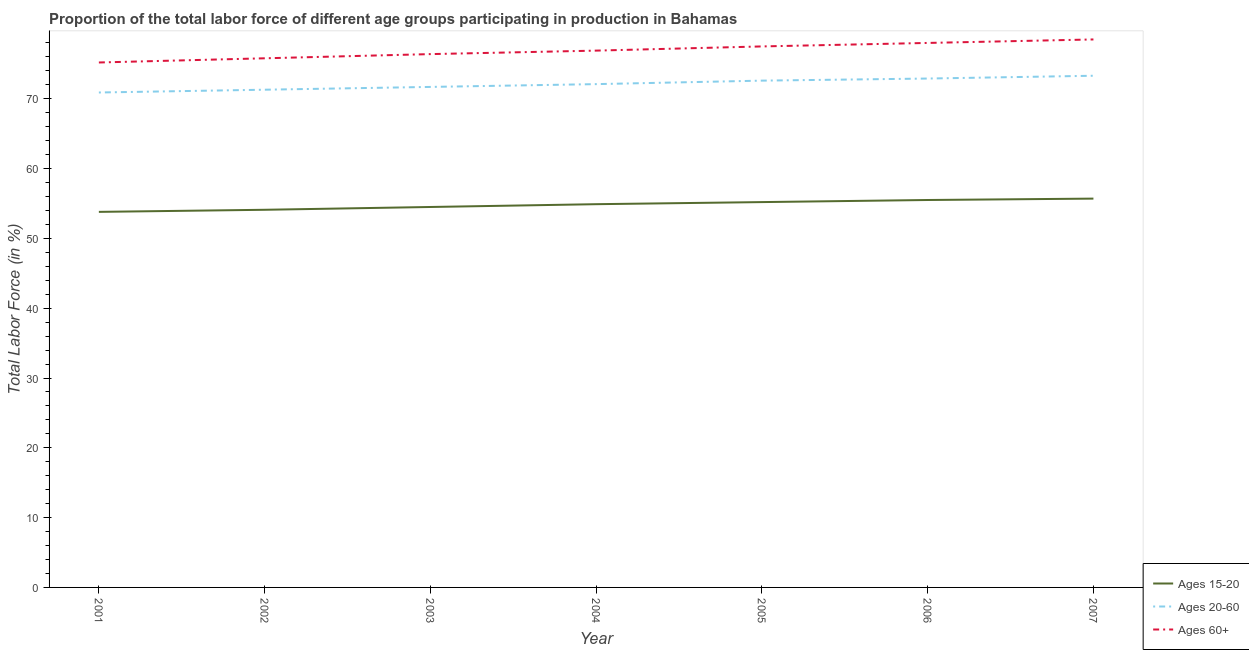What is the percentage of labor force within the age group 15-20 in 2001?
Offer a very short reply. 53.8. Across all years, what is the maximum percentage of labor force above age 60?
Provide a short and direct response. 78.5. Across all years, what is the minimum percentage of labor force within the age group 20-60?
Offer a very short reply. 70.9. In which year was the percentage of labor force within the age group 20-60 minimum?
Offer a terse response. 2001. What is the total percentage of labor force above age 60 in the graph?
Keep it short and to the point. 538.3. What is the difference between the percentage of labor force within the age group 15-20 in 2001 and that in 2005?
Provide a short and direct response. -1.4. What is the difference between the percentage of labor force above age 60 in 2007 and the percentage of labor force within the age group 15-20 in 2001?
Your response must be concise. 24.7. What is the average percentage of labor force within the age group 15-20 per year?
Your answer should be compact. 54.81. In the year 2005, what is the difference between the percentage of labor force within the age group 15-20 and percentage of labor force within the age group 20-60?
Your answer should be very brief. -17.4. In how many years, is the percentage of labor force within the age group 20-60 greater than 74 %?
Provide a short and direct response. 0. What is the ratio of the percentage of labor force above age 60 in 2001 to that in 2002?
Provide a succinct answer. 0.99. Is the percentage of labor force within the age group 20-60 in 2002 less than that in 2005?
Offer a terse response. Yes. Is the difference between the percentage of labor force within the age group 15-20 in 2002 and 2005 greater than the difference between the percentage of labor force within the age group 20-60 in 2002 and 2005?
Keep it short and to the point. Yes. What is the difference between the highest and the second highest percentage of labor force within the age group 15-20?
Provide a short and direct response. 0.2. What is the difference between the highest and the lowest percentage of labor force within the age group 20-60?
Make the answer very short. 2.4. Is the sum of the percentage of labor force within the age group 15-20 in 2002 and 2003 greater than the maximum percentage of labor force above age 60 across all years?
Offer a terse response. Yes. Is it the case that in every year, the sum of the percentage of labor force within the age group 15-20 and percentage of labor force within the age group 20-60 is greater than the percentage of labor force above age 60?
Offer a very short reply. Yes. Does the percentage of labor force above age 60 monotonically increase over the years?
Ensure brevity in your answer.  Yes. Is the percentage of labor force above age 60 strictly greater than the percentage of labor force within the age group 20-60 over the years?
Ensure brevity in your answer.  Yes. How many lines are there?
Offer a terse response. 3. What is the difference between two consecutive major ticks on the Y-axis?
Provide a succinct answer. 10. Where does the legend appear in the graph?
Keep it short and to the point. Bottom right. How many legend labels are there?
Keep it short and to the point. 3. What is the title of the graph?
Provide a succinct answer. Proportion of the total labor force of different age groups participating in production in Bahamas. Does "Taxes on goods and services" appear as one of the legend labels in the graph?
Make the answer very short. No. What is the label or title of the Y-axis?
Your answer should be compact. Total Labor Force (in %). What is the Total Labor Force (in %) of Ages 15-20 in 2001?
Give a very brief answer. 53.8. What is the Total Labor Force (in %) of Ages 20-60 in 2001?
Your answer should be very brief. 70.9. What is the Total Labor Force (in %) in Ages 60+ in 2001?
Make the answer very short. 75.2. What is the Total Labor Force (in %) in Ages 15-20 in 2002?
Your answer should be compact. 54.1. What is the Total Labor Force (in %) of Ages 20-60 in 2002?
Keep it short and to the point. 71.3. What is the Total Labor Force (in %) in Ages 60+ in 2002?
Offer a terse response. 75.8. What is the Total Labor Force (in %) of Ages 15-20 in 2003?
Make the answer very short. 54.5. What is the Total Labor Force (in %) in Ages 20-60 in 2003?
Provide a succinct answer. 71.7. What is the Total Labor Force (in %) of Ages 60+ in 2003?
Ensure brevity in your answer.  76.4. What is the Total Labor Force (in %) in Ages 15-20 in 2004?
Your answer should be compact. 54.9. What is the Total Labor Force (in %) in Ages 20-60 in 2004?
Provide a succinct answer. 72.1. What is the Total Labor Force (in %) in Ages 60+ in 2004?
Ensure brevity in your answer.  76.9. What is the Total Labor Force (in %) of Ages 15-20 in 2005?
Your answer should be compact. 55.2. What is the Total Labor Force (in %) in Ages 20-60 in 2005?
Your response must be concise. 72.6. What is the Total Labor Force (in %) in Ages 60+ in 2005?
Offer a terse response. 77.5. What is the Total Labor Force (in %) in Ages 15-20 in 2006?
Offer a terse response. 55.5. What is the Total Labor Force (in %) in Ages 20-60 in 2006?
Keep it short and to the point. 72.9. What is the Total Labor Force (in %) of Ages 60+ in 2006?
Provide a succinct answer. 78. What is the Total Labor Force (in %) in Ages 15-20 in 2007?
Keep it short and to the point. 55.7. What is the Total Labor Force (in %) of Ages 20-60 in 2007?
Keep it short and to the point. 73.3. What is the Total Labor Force (in %) of Ages 60+ in 2007?
Provide a succinct answer. 78.5. Across all years, what is the maximum Total Labor Force (in %) in Ages 15-20?
Your response must be concise. 55.7. Across all years, what is the maximum Total Labor Force (in %) of Ages 20-60?
Keep it short and to the point. 73.3. Across all years, what is the maximum Total Labor Force (in %) in Ages 60+?
Offer a terse response. 78.5. Across all years, what is the minimum Total Labor Force (in %) of Ages 15-20?
Offer a terse response. 53.8. Across all years, what is the minimum Total Labor Force (in %) of Ages 20-60?
Ensure brevity in your answer.  70.9. Across all years, what is the minimum Total Labor Force (in %) of Ages 60+?
Provide a succinct answer. 75.2. What is the total Total Labor Force (in %) in Ages 15-20 in the graph?
Provide a succinct answer. 383.7. What is the total Total Labor Force (in %) in Ages 20-60 in the graph?
Your answer should be compact. 504.8. What is the total Total Labor Force (in %) of Ages 60+ in the graph?
Provide a short and direct response. 538.3. What is the difference between the Total Labor Force (in %) of Ages 15-20 in 2001 and that in 2002?
Your answer should be very brief. -0.3. What is the difference between the Total Labor Force (in %) of Ages 60+ in 2001 and that in 2002?
Make the answer very short. -0.6. What is the difference between the Total Labor Force (in %) of Ages 15-20 in 2001 and that in 2003?
Offer a very short reply. -0.7. What is the difference between the Total Labor Force (in %) of Ages 20-60 in 2001 and that in 2003?
Offer a very short reply. -0.8. What is the difference between the Total Labor Force (in %) in Ages 20-60 in 2001 and that in 2004?
Provide a short and direct response. -1.2. What is the difference between the Total Labor Force (in %) in Ages 60+ in 2001 and that in 2004?
Give a very brief answer. -1.7. What is the difference between the Total Labor Force (in %) of Ages 20-60 in 2001 and that in 2005?
Keep it short and to the point. -1.7. What is the difference between the Total Labor Force (in %) in Ages 15-20 in 2001 and that in 2007?
Provide a succinct answer. -1.9. What is the difference between the Total Labor Force (in %) of Ages 60+ in 2001 and that in 2007?
Your answer should be compact. -3.3. What is the difference between the Total Labor Force (in %) of Ages 15-20 in 2002 and that in 2003?
Provide a succinct answer. -0.4. What is the difference between the Total Labor Force (in %) of Ages 60+ in 2002 and that in 2003?
Make the answer very short. -0.6. What is the difference between the Total Labor Force (in %) in Ages 15-20 in 2002 and that in 2004?
Your answer should be very brief. -0.8. What is the difference between the Total Labor Force (in %) of Ages 20-60 in 2002 and that in 2004?
Give a very brief answer. -0.8. What is the difference between the Total Labor Force (in %) of Ages 15-20 in 2002 and that in 2005?
Make the answer very short. -1.1. What is the difference between the Total Labor Force (in %) of Ages 20-60 in 2002 and that in 2005?
Your response must be concise. -1.3. What is the difference between the Total Labor Force (in %) of Ages 60+ in 2002 and that in 2005?
Offer a very short reply. -1.7. What is the difference between the Total Labor Force (in %) of Ages 15-20 in 2002 and that in 2006?
Offer a very short reply. -1.4. What is the difference between the Total Labor Force (in %) in Ages 20-60 in 2002 and that in 2006?
Offer a very short reply. -1.6. What is the difference between the Total Labor Force (in %) in Ages 60+ in 2002 and that in 2006?
Keep it short and to the point. -2.2. What is the difference between the Total Labor Force (in %) of Ages 15-20 in 2002 and that in 2007?
Your response must be concise. -1.6. What is the difference between the Total Labor Force (in %) in Ages 20-60 in 2003 and that in 2004?
Offer a very short reply. -0.4. What is the difference between the Total Labor Force (in %) of Ages 60+ in 2003 and that in 2005?
Ensure brevity in your answer.  -1.1. What is the difference between the Total Labor Force (in %) of Ages 20-60 in 2003 and that in 2006?
Your answer should be very brief. -1.2. What is the difference between the Total Labor Force (in %) in Ages 20-60 in 2003 and that in 2007?
Keep it short and to the point. -1.6. What is the difference between the Total Labor Force (in %) of Ages 60+ in 2003 and that in 2007?
Ensure brevity in your answer.  -2.1. What is the difference between the Total Labor Force (in %) in Ages 20-60 in 2004 and that in 2005?
Provide a short and direct response. -0.5. What is the difference between the Total Labor Force (in %) in Ages 60+ in 2004 and that in 2005?
Your answer should be very brief. -0.6. What is the difference between the Total Labor Force (in %) of Ages 15-20 in 2004 and that in 2006?
Make the answer very short. -0.6. What is the difference between the Total Labor Force (in %) in Ages 20-60 in 2004 and that in 2006?
Your answer should be very brief. -0.8. What is the difference between the Total Labor Force (in %) in Ages 60+ in 2004 and that in 2006?
Ensure brevity in your answer.  -1.1. What is the difference between the Total Labor Force (in %) in Ages 60+ in 2004 and that in 2007?
Offer a very short reply. -1.6. What is the difference between the Total Labor Force (in %) in Ages 20-60 in 2005 and that in 2006?
Make the answer very short. -0.3. What is the difference between the Total Labor Force (in %) of Ages 60+ in 2005 and that in 2006?
Make the answer very short. -0.5. What is the difference between the Total Labor Force (in %) of Ages 20-60 in 2005 and that in 2007?
Offer a terse response. -0.7. What is the difference between the Total Labor Force (in %) of Ages 60+ in 2005 and that in 2007?
Make the answer very short. -1. What is the difference between the Total Labor Force (in %) in Ages 20-60 in 2006 and that in 2007?
Offer a very short reply. -0.4. What is the difference between the Total Labor Force (in %) in Ages 60+ in 2006 and that in 2007?
Offer a very short reply. -0.5. What is the difference between the Total Labor Force (in %) in Ages 15-20 in 2001 and the Total Labor Force (in %) in Ages 20-60 in 2002?
Your answer should be very brief. -17.5. What is the difference between the Total Labor Force (in %) in Ages 15-20 in 2001 and the Total Labor Force (in %) in Ages 20-60 in 2003?
Give a very brief answer. -17.9. What is the difference between the Total Labor Force (in %) in Ages 15-20 in 2001 and the Total Labor Force (in %) in Ages 60+ in 2003?
Ensure brevity in your answer.  -22.6. What is the difference between the Total Labor Force (in %) in Ages 20-60 in 2001 and the Total Labor Force (in %) in Ages 60+ in 2003?
Your response must be concise. -5.5. What is the difference between the Total Labor Force (in %) of Ages 15-20 in 2001 and the Total Labor Force (in %) of Ages 20-60 in 2004?
Provide a succinct answer. -18.3. What is the difference between the Total Labor Force (in %) in Ages 15-20 in 2001 and the Total Labor Force (in %) in Ages 60+ in 2004?
Give a very brief answer. -23.1. What is the difference between the Total Labor Force (in %) in Ages 15-20 in 2001 and the Total Labor Force (in %) in Ages 20-60 in 2005?
Ensure brevity in your answer.  -18.8. What is the difference between the Total Labor Force (in %) of Ages 15-20 in 2001 and the Total Labor Force (in %) of Ages 60+ in 2005?
Give a very brief answer. -23.7. What is the difference between the Total Labor Force (in %) in Ages 15-20 in 2001 and the Total Labor Force (in %) in Ages 20-60 in 2006?
Give a very brief answer. -19.1. What is the difference between the Total Labor Force (in %) in Ages 15-20 in 2001 and the Total Labor Force (in %) in Ages 60+ in 2006?
Provide a short and direct response. -24.2. What is the difference between the Total Labor Force (in %) of Ages 15-20 in 2001 and the Total Labor Force (in %) of Ages 20-60 in 2007?
Offer a terse response. -19.5. What is the difference between the Total Labor Force (in %) of Ages 15-20 in 2001 and the Total Labor Force (in %) of Ages 60+ in 2007?
Ensure brevity in your answer.  -24.7. What is the difference between the Total Labor Force (in %) in Ages 20-60 in 2001 and the Total Labor Force (in %) in Ages 60+ in 2007?
Your answer should be compact. -7.6. What is the difference between the Total Labor Force (in %) in Ages 15-20 in 2002 and the Total Labor Force (in %) in Ages 20-60 in 2003?
Offer a terse response. -17.6. What is the difference between the Total Labor Force (in %) of Ages 15-20 in 2002 and the Total Labor Force (in %) of Ages 60+ in 2003?
Offer a very short reply. -22.3. What is the difference between the Total Labor Force (in %) of Ages 20-60 in 2002 and the Total Labor Force (in %) of Ages 60+ in 2003?
Make the answer very short. -5.1. What is the difference between the Total Labor Force (in %) of Ages 15-20 in 2002 and the Total Labor Force (in %) of Ages 20-60 in 2004?
Offer a very short reply. -18. What is the difference between the Total Labor Force (in %) in Ages 15-20 in 2002 and the Total Labor Force (in %) in Ages 60+ in 2004?
Keep it short and to the point. -22.8. What is the difference between the Total Labor Force (in %) in Ages 15-20 in 2002 and the Total Labor Force (in %) in Ages 20-60 in 2005?
Keep it short and to the point. -18.5. What is the difference between the Total Labor Force (in %) in Ages 15-20 in 2002 and the Total Labor Force (in %) in Ages 60+ in 2005?
Your answer should be very brief. -23.4. What is the difference between the Total Labor Force (in %) in Ages 15-20 in 2002 and the Total Labor Force (in %) in Ages 20-60 in 2006?
Make the answer very short. -18.8. What is the difference between the Total Labor Force (in %) in Ages 15-20 in 2002 and the Total Labor Force (in %) in Ages 60+ in 2006?
Provide a short and direct response. -23.9. What is the difference between the Total Labor Force (in %) of Ages 15-20 in 2002 and the Total Labor Force (in %) of Ages 20-60 in 2007?
Your response must be concise. -19.2. What is the difference between the Total Labor Force (in %) in Ages 15-20 in 2002 and the Total Labor Force (in %) in Ages 60+ in 2007?
Provide a short and direct response. -24.4. What is the difference between the Total Labor Force (in %) of Ages 20-60 in 2002 and the Total Labor Force (in %) of Ages 60+ in 2007?
Make the answer very short. -7.2. What is the difference between the Total Labor Force (in %) of Ages 15-20 in 2003 and the Total Labor Force (in %) of Ages 20-60 in 2004?
Your response must be concise. -17.6. What is the difference between the Total Labor Force (in %) in Ages 15-20 in 2003 and the Total Labor Force (in %) in Ages 60+ in 2004?
Your answer should be compact. -22.4. What is the difference between the Total Labor Force (in %) in Ages 20-60 in 2003 and the Total Labor Force (in %) in Ages 60+ in 2004?
Provide a short and direct response. -5.2. What is the difference between the Total Labor Force (in %) in Ages 15-20 in 2003 and the Total Labor Force (in %) in Ages 20-60 in 2005?
Your response must be concise. -18.1. What is the difference between the Total Labor Force (in %) of Ages 20-60 in 2003 and the Total Labor Force (in %) of Ages 60+ in 2005?
Keep it short and to the point. -5.8. What is the difference between the Total Labor Force (in %) in Ages 15-20 in 2003 and the Total Labor Force (in %) in Ages 20-60 in 2006?
Your response must be concise. -18.4. What is the difference between the Total Labor Force (in %) of Ages 15-20 in 2003 and the Total Labor Force (in %) of Ages 60+ in 2006?
Your response must be concise. -23.5. What is the difference between the Total Labor Force (in %) of Ages 20-60 in 2003 and the Total Labor Force (in %) of Ages 60+ in 2006?
Provide a succinct answer. -6.3. What is the difference between the Total Labor Force (in %) of Ages 15-20 in 2003 and the Total Labor Force (in %) of Ages 20-60 in 2007?
Your answer should be very brief. -18.8. What is the difference between the Total Labor Force (in %) of Ages 15-20 in 2003 and the Total Labor Force (in %) of Ages 60+ in 2007?
Your answer should be compact. -24. What is the difference between the Total Labor Force (in %) in Ages 20-60 in 2003 and the Total Labor Force (in %) in Ages 60+ in 2007?
Offer a terse response. -6.8. What is the difference between the Total Labor Force (in %) in Ages 15-20 in 2004 and the Total Labor Force (in %) in Ages 20-60 in 2005?
Give a very brief answer. -17.7. What is the difference between the Total Labor Force (in %) in Ages 15-20 in 2004 and the Total Labor Force (in %) in Ages 60+ in 2005?
Keep it short and to the point. -22.6. What is the difference between the Total Labor Force (in %) in Ages 15-20 in 2004 and the Total Labor Force (in %) in Ages 20-60 in 2006?
Make the answer very short. -18. What is the difference between the Total Labor Force (in %) of Ages 15-20 in 2004 and the Total Labor Force (in %) of Ages 60+ in 2006?
Your answer should be very brief. -23.1. What is the difference between the Total Labor Force (in %) of Ages 15-20 in 2004 and the Total Labor Force (in %) of Ages 20-60 in 2007?
Provide a short and direct response. -18.4. What is the difference between the Total Labor Force (in %) of Ages 15-20 in 2004 and the Total Labor Force (in %) of Ages 60+ in 2007?
Your answer should be very brief. -23.6. What is the difference between the Total Labor Force (in %) in Ages 20-60 in 2004 and the Total Labor Force (in %) in Ages 60+ in 2007?
Your answer should be very brief. -6.4. What is the difference between the Total Labor Force (in %) of Ages 15-20 in 2005 and the Total Labor Force (in %) of Ages 20-60 in 2006?
Ensure brevity in your answer.  -17.7. What is the difference between the Total Labor Force (in %) of Ages 15-20 in 2005 and the Total Labor Force (in %) of Ages 60+ in 2006?
Keep it short and to the point. -22.8. What is the difference between the Total Labor Force (in %) in Ages 20-60 in 2005 and the Total Labor Force (in %) in Ages 60+ in 2006?
Ensure brevity in your answer.  -5.4. What is the difference between the Total Labor Force (in %) of Ages 15-20 in 2005 and the Total Labor Force (in %) of Ages 20-60 in 2007?
Your response must be concise. -18.1. What is the difference between the Total Labor Force (in %) in Ages 15-20 in 2005 and the Total Labor Force (in %) in Ages 60+ in 2007?
Provide a succinct answer. -23.3. What is the difference between the Total Labor Force (in %) in Ages 20-60 in 2005 and the Total Labor Force (in %) in Ages 60+ in 2007?
Ensure brevity in your answer.  -5.9. What is the difference between the Total Labor Force (in %) of Ages 15-20 in 2006 and the Total Labor Force (in %) of Ages 20-60 in 2007?
Your response must be concise. -17.8. What is the average Total Labor Force (in %) in Ages 15-20 per year?
Provide a short and direct response. 54.81. What is the average Total Labor Force (in %) of Ages 20-60 per year?
Provide a short and direct response. 72.11. What is the average Total Labor Force (in %) of Ages 60+ per year?
Offer a terse response. 76.9. In the year 2001, what is the difference between the Total Labor Force (in %) of Ages 15-20 and Total Labor Force (in %) of Ages 20-60?
Your answer should be compact. -17.1. In the year 2001, what is the difference between the Total Labor Force (in %) in Ages 15-20 and Total Labor Force (in %) in Ages 60+?
Provide a succinct answer. -21.4. In the year 2001, what is the difference between the Total Labor Force (in %) in Ages 20-60 and Total Labor Force (in %) in Ages 60+?
Your response must be concise. -4.3. In the year 2002, what is the difference between the Total Labor Force (in %) in Ages 15-20 and Total Labor Force (in %) in Ages 20-60?
Give a very brief answer. -17.2. In the year 2002, what is the difference between the Total Labor Force (in %) in Ages 15-20 and Total Labor Force (in %) in Ages 60+?
Offer a very short reply. -21.7. In the year 2003, what is the difference between the Total Labor Force (in %) of Ages 15-20 and Total Labor Force (in %) of Ages 20-60?
Your answer should be compact. -17.2. In the year 2003, what is the difference between the Total Labor Force (in %) of Ages 15-20 and Total Labor Force (in %) of Ages 60+?
Provide a succinct answer. -21.9. In the year 2003, what is the difference between the Total Labor Force (in %) in Ages 20-60 and Total Labor Force (in %) in Ages 60+?
Offer a very short reply. -4.7. In the year 2004, what is the difference between the Total Labor Force (in %) in Ages 15-20 and Total Labor Force (in %) in Ages 20-60?
Your response must be concise. -17.2. In the year 2004, what is the difference between the Total Labor Force (in %) of Ages 15-20 and Total Labor Force (in %) of Ages 60+?
Your response must be concise. -22. In the year 2005, what is the difference between the Total Labor Force (in %) in Ages 15-20 and Total Labor Force (in %) in Ages 20-60?
Offer a very short reply. -17.4. In the year 2005, what is the difference between the Total Labor Force (in %) in Ages 15-20 and Total Labor Force (in %) in Ages 60+?
Give a very brief answer. -22.3. In the year 2006, what is the difference between the Total Labor Force (in %) in Ages 15-20 and Total Labor Force (in %) in Ages 20-60?
Provide a short and direct response. -17.4. In the year 2006, what is the difference between the Total Labor Force (in %) in Ages 15-20 and Total Labor Force (in %) in Ages 60+?
Provide a succinct answer. -22.5. In the year 2007, what is the difference between the Total Labor Force (in %) in Ages 15-20 and Total Labor Force (in %) in Ages 20-60?
Provide a succinct answer. -17.6. In the year 2007, what is the difference between the Total Labor Force (in %) in Ages 15-20 and Total Labor Force (in %) in Ages 60+?
Keep it short and to the point. -22.8. What is the ratio of the Total Labor Force (in %) of Ages 15-20 in 2001 to that in 2002?
Your response must be concise. 0.99. What is the ratio of the Total Labor Force (in %) in Ages 15-20 in 2001 to that in 2003?
Your answer should be very brief. 0.99. What is the ratio of the Total Labor Force (in %) of Ages 20-60 in 2001 to that in 2003?
Offer a very short reply. 0.99. What is the ratio of the Total Labor Force (in %) in Ages 60+ in 2001 to that in 2003?
Your answer should be compact. 0.98. What is the ratio of the Total Labor Force (in %) in Ages 20-60 in 2001 to that in 2004?
Your response must be concise. 0.98. What is the ratio of the Total Labor Force (in %) of Ages 60+ in 2001 to that in 2004?
Provide a short and direct response. 0.98. What is the ratio of the Total Labor Force (in %) in Ages 15-20 in 2001 to that in 2005?
Offer a very short reply. 0.97. What is the ratio of the Total Labor Force (in %) of Ages 20-60 in 2001 to that in 2005?
Ensure brevity in your answer.  0.98. What is the ratio of the Total Labor Force (in %) in Ages 60+ in 2001 to that in 2005?
Give a very brief answer. 0.97. What is the ratio of the Total Labor Force (in %) of Ages 15-20 in 2001 to that in 2006?
Provide a succinct answer. 0.97. What is the ratio of the Total Labor Force (in %) in Ages 20-60 in 2001 to that in 2006?
Offer a very short reply. 0.97. What is the ratio of the Total Labor Force (in %) of Ages 60+ in 2001 to that in 2006?
Give a very brief answer. 0.96. What is the ratio of the Total Labor Force (in %) in Ages 15-20 in 2001 to that in 2007?
Offer a terse response. 0.97. What is the ratio of the Total Labor Force (in %) of Ages 20-60 in 2001 to that in 2007?
Your answer should be very brief. 0.97. What is the ratio of the Total Labor Force (in %) of Ages 60+ in 2001 to that in 2007?
Keep it short and to the point. 0.96. What is the ratio of the Total Labor Force (in %) of Ages 60+ in 2002 to that in 2003?
Offer a terse response. 0.99. What is the ratio of the Total Labor Force (in %) of Ages 15-20 in 2002 to that in 2004?
Your answer should be compact. 0.99. What is the ratio of the Total Labor Force (in %) of Ages 20-60 in 2002 to that in 2004?
Provide a short and direct response. 0.99. What is the ratio of the Total Labor Force (in %) in Ages 60+ in 2002 to that in 2004?
Make the answer very short. 0.99. What is the ratio of the Total Labor Force (in %) of Ages 15-20 in 2002 to that in 2005?
Provide a short and direct response. 0.98. What is the ratio of the Total Labor Force (in %) in Ages 20-60 in 2002 to that in 2005?
Offer a very short reply. 0.98. What is the ratio of the Total Labor Force (in %) in Ages 60+ in 2002 to that in 2005?
Provide a short and direct response. 0.98. What is the ratio of the Total Labor Force (in %) of Ages 15-20 in 2002 to that in 2006?
Offer a very short reply. 0.97. What is the ratio of the Total Labor Force (in %) in Ages 20-60 in 2002 to that in 2006?
Offer a very short reply. 0.98. What is the ratio of the Total Labor Force (in %) of Ages 60+ in 2002 to that in 2006?
Keep it short and to the point. 0.97. What is the ratio of the Total Labor Force (in %) of Ages 15-20 in 2002 to that in 2007?
Provide a succinct answer. 0.97. What is the ratio of the Total Labor Force (in %) in Ages 20-60 in 2002 to that in 2007?
Offer a very short reply. 0.97. What is the ratio of the Total Labor Force (in %) of Ages 60+ in 2002 to that in 2007?
Provide a short and direct response. 0.97. What is the ratio of the Total Labor Force (in %) of Ages 20-60 in 2003 to that in 2004?
Give a very brief answer. 0.99. What is the ratio of the Total Labor Force (in %) of Ages 15-20 in 2003 to that in 2005?
Give a very brief answer. 0.99. What is the ratio of the Total Labor Force (in %) in Ages 20-60 in 2003 to that in 2005?
Your answer should be very brief. 0.99. What is the ratio of the Total Labor Force (in %) in Ages 60+ in 2003 to that in 2005?
Offer a terse response. 0.99. What is the ratio of the Total Labor Force (in %) in Ages 15-20 in 2003 to that in 2006?
Offer a very short reply. 0.98. What is the ratio of the Total Labor Force (in %) of Ages 20-60 in 2003 to that in 2006?
Ensure brevity in your answer.  0.98. What is the ratio of the Total Labor Force (in %) of Ages 60+ in 2003 to that in 2006?
Give a very brief answer. 0.98. What is the ratio of the Total Labor Force (in %) in Ages 15-20 in 2003 to that in 2007?
Your answer should be compact. 0.98. What is the ratio of the Total Labor Force (in %) in Ages 20-60 in 2003 to that in 2007?
Give a very brief answer. 0.98. What is the ratio of the Total Labor Force (in %) in Ages 60+ in 2003 to that in 2007?
Offer a terse response. 0.97. What is the ratio of the Total Labor Force (in %) in Ages 15-20 in 2004 to that in 2006?
Your answer should be compact. 0.99. What is the ratio of the Total Labor Force (in %) in Ages 20-60 in 2004 to that in 2006?
Your response must be concise. 0.99. What is the ratio of the Total Labor Force (in %) of Ages 60+ in 2004 to that in 2006?
Offer a terse response. 0.99. What is the ratio of the Total Labor Force (in %) in Ages 15-20 in 2004 to that in 2007?
Your answer should be very brief. 0.99. What is the ratio of the Total Labor Force (in %) in Ages 20-60 in 2004 to that in 2007?
Your response must be concise. 0.98. What is the ratio of the Total Labor Force (in %) of Ages 60+ in 2004 to that in 2007?
Provide a succinct answer. 0.98. What is the ratio of the Total Labor Force (in %) in Ages 20-60 in 2005 to that in 2006?
Ensure brevity in your answer.  1. What is the ratio of the Total Labor Force (in %) in Ages 60+ in 2005 to that in 2006?
Your answer should be very brief. 0.99. What is the ratio of the Total Labor Force (in %) of Ages 15-20 in 2005 to that in 2007?
Your answer should be compact. 0.99. What is the ratio of the Total Labor Force (in %) in Ages 60+ in 2005 to that in 2007?
Your answer should be very brief. 0.99. What is the ratio of the Total Labor Force (in %) of Ages 20-60 in 2006 to that in 2007?
Provide a short and direct response. 0.99. What is the ratio of the Total Labor Force (in %) in Ages 60+ in 2006 to that in 2007?
Your answer should be compact. 0.99. What is the difference between the highest and the second highest Total Labor Force (in %) in Ages 15-20?
Your response must be concise. 0.2. What is the difference between the highest and the second highest Total Labor Force (in %) in Ages 20-60?
Your answer should be compact. 0.4. What is the difference between the highest and the second highest Total Labor Force (in %) of Ages 60+?
Offer a very short reply. 0.5. What is the difference between the highest and the lowest Total Labor Force (in %) of Ages 15-20?
Give a very brief answer. 1.9. What is the difference between the highest and the lowest Total Labor Force (in %) in Ages 60+?
Keep it short and to the point. 3.3. 